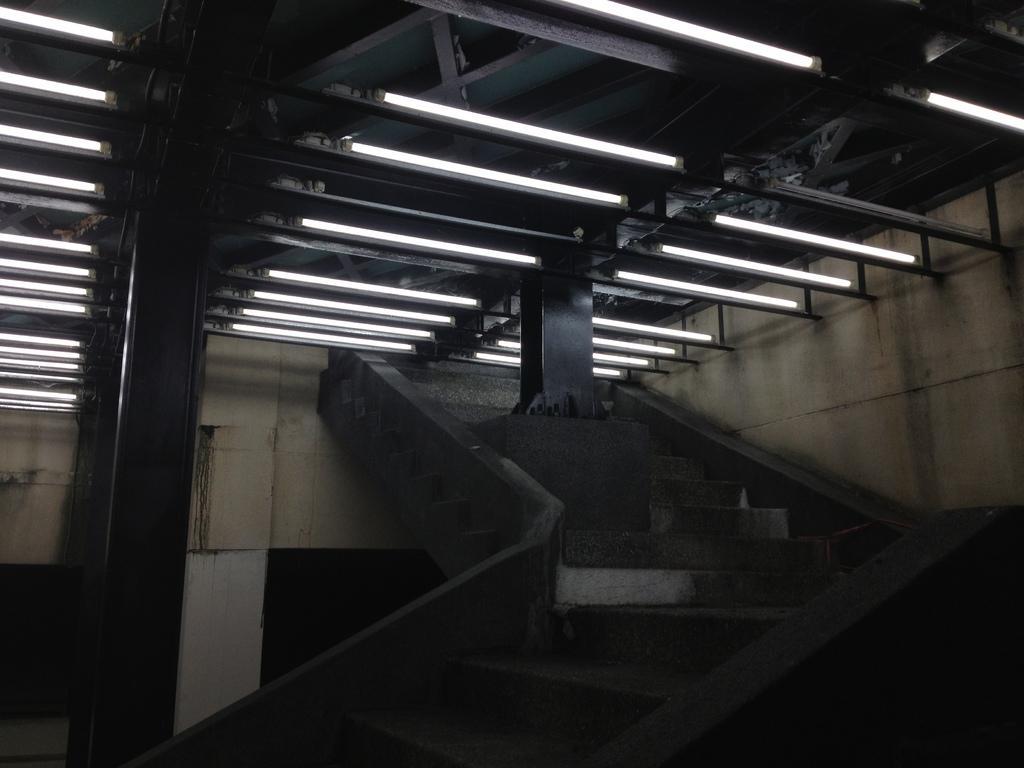Could you give a brief overview of what you see in this image? In this image we can see stairs, wall and some lights attached to the roof. 